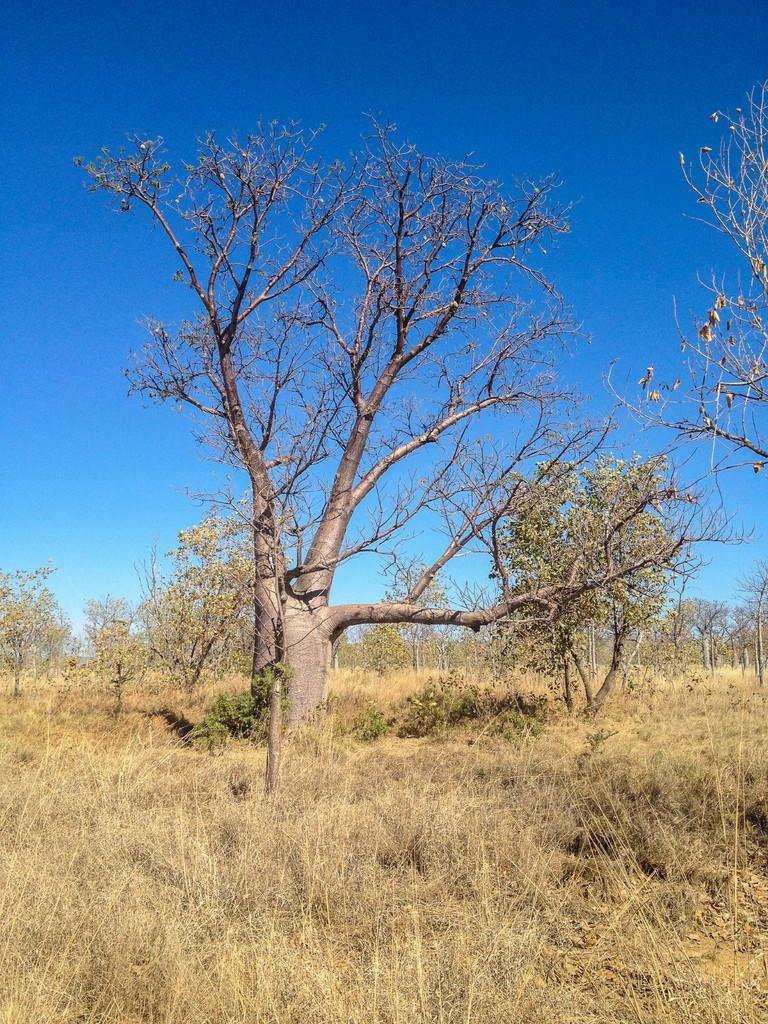What type of vegetation can be seen in the image? There are trees, plants, and grass in the image. What is visible in the sky in the image? The sky is clear in the image. What is the price of the copy of the book in the image? There is no book or price mentioned in the image; it only features trees, plants, grass, and a clear sky. 